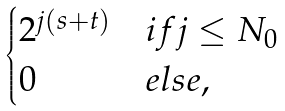<formula> <loc_0><loc_0><loc_500><loc_500>\begin{cases} 2 ^ { j ( s + t ) } & i f j \leq N _ { 0 } \\ 0 & e l s e , \end{cases}</formula> 